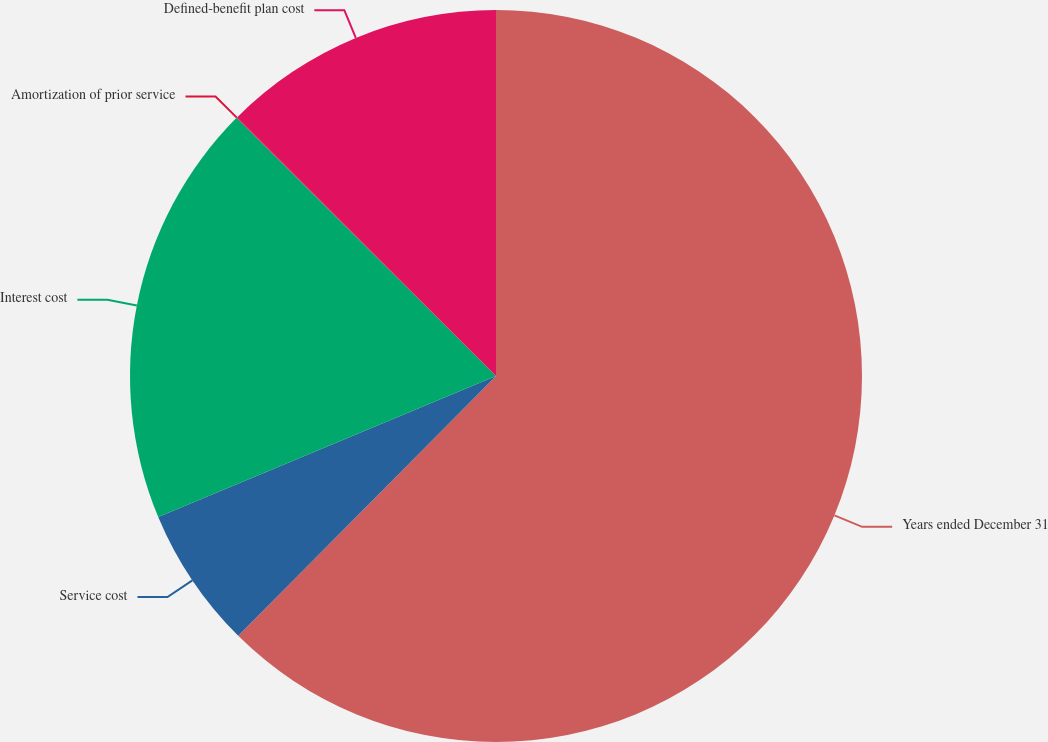Convert chart. <chart><loc_0><loc_0><loc_500><loc_500><pie_chart><fcel>Years ended December 31<fcel>Service cost<fcel>Interest cost<fcel>Amortization of prior service<fcel>Defined-benefit plan cost<nl><fcel>62.43%<fcel>6.27%<fcel>18.75%<fcel>0.03%<fcel>12.51%<nl></chart> 